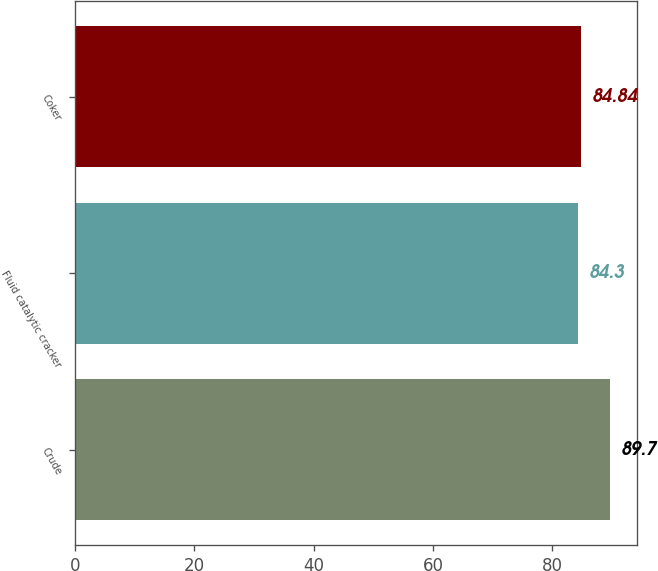<chart> <loc_0><loc_0><loc_500><loc_500><bar_chart><fcel>Crude<fcel>Fluid catalytic cracker<fcel>Coker<nl><fcel>89.7<fcel>84.3<fcel>84.84<nl></chart> 